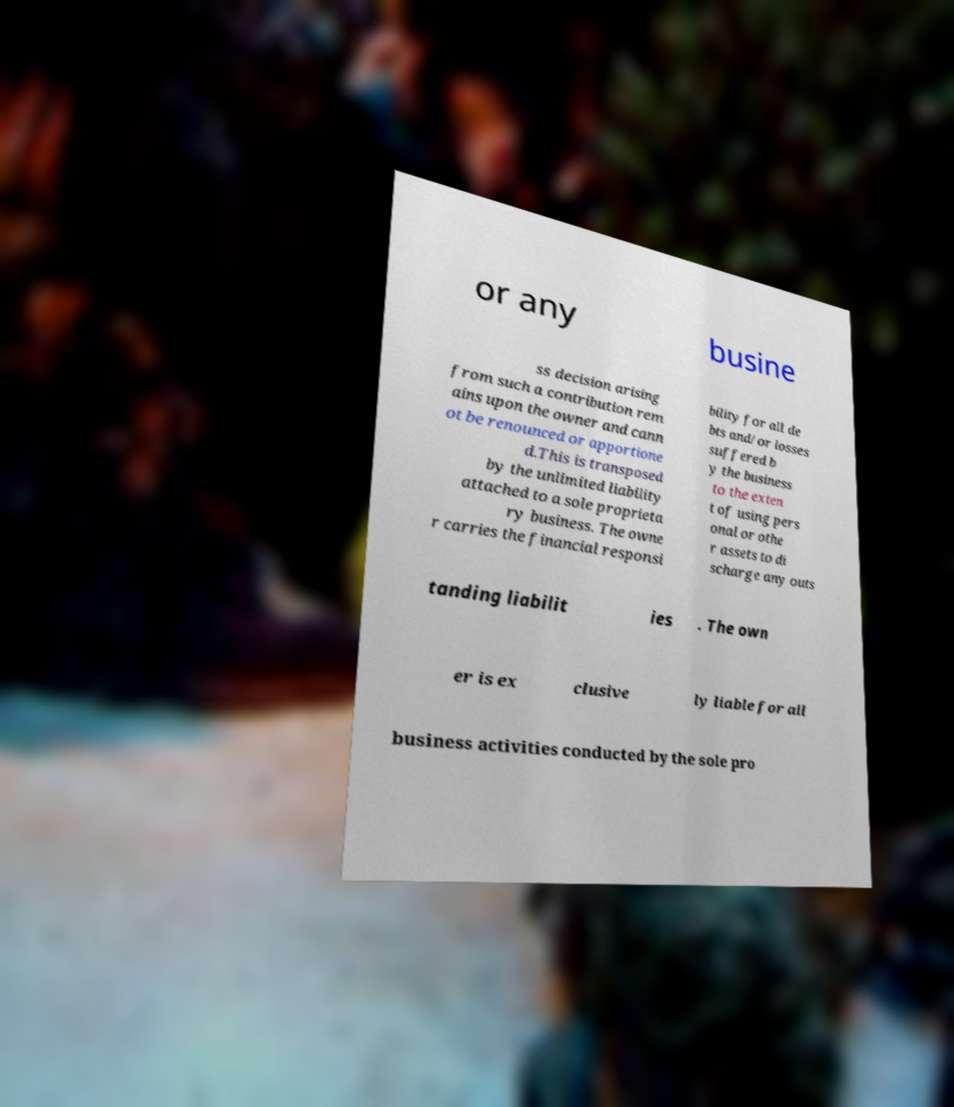Could you extract and type out the text from this image? or any busine ss decision arising from such a contribution rem ains upon the owner and cann ot be renounced or apportione d.This is transposed by the unlimited liability attached to a sole proprieta ry business. The owne r carries the financial responsi bility for all de bts and/or losses suffered b y the business to the exten t of using pers onal or othe r assets to di scharge any outs tanding liabilit ies . The own er is ex clusive ly liable for all business activities conducted by the sole pro 